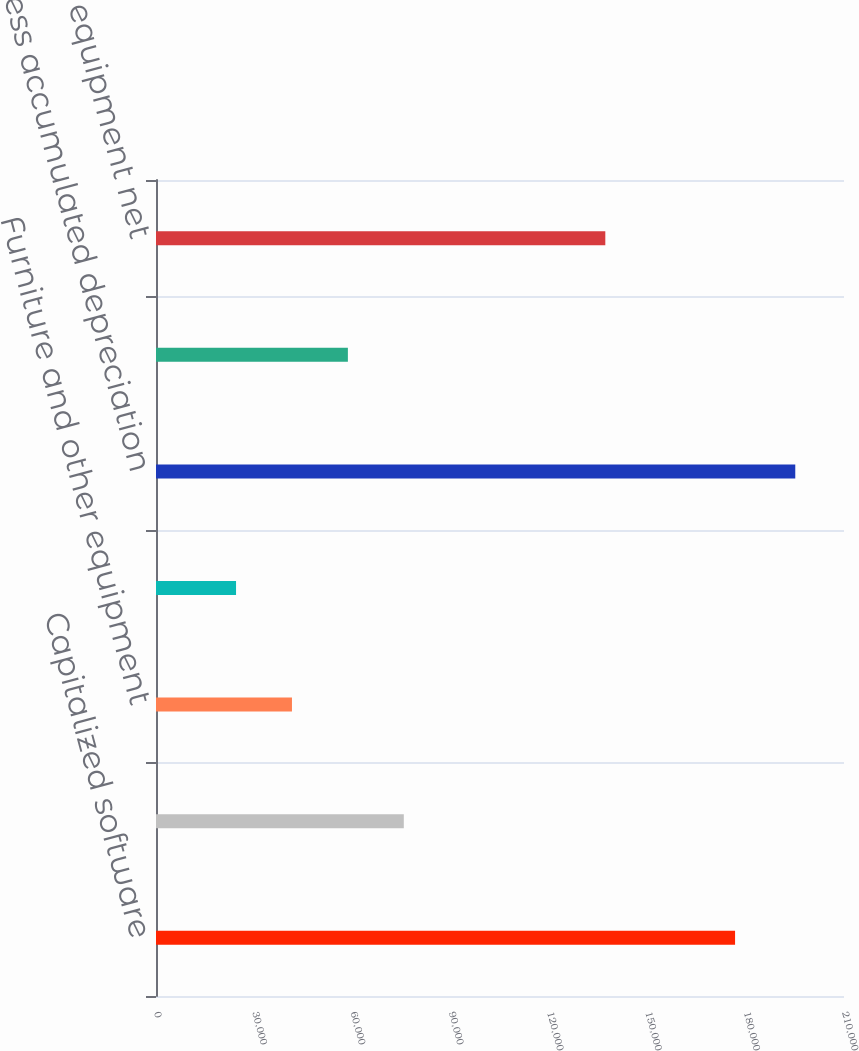<chart> <loc_0><loc_0><loc_500><loc_500><bar_chart><fcel>Capitalized software<fcel>Computer equipment<fcel>Furniture and other equipment<fcel>Leasehold improvements<fcel>Less accumulated depreciation<fcel>Projects in progress<fcel>Property and equipment net<nl><fcel>176751<fcel>75639.5<fcel>41500.5<fcel>24431<fcel>195126<fcel>58570<fcel>137144<nl></chart> 